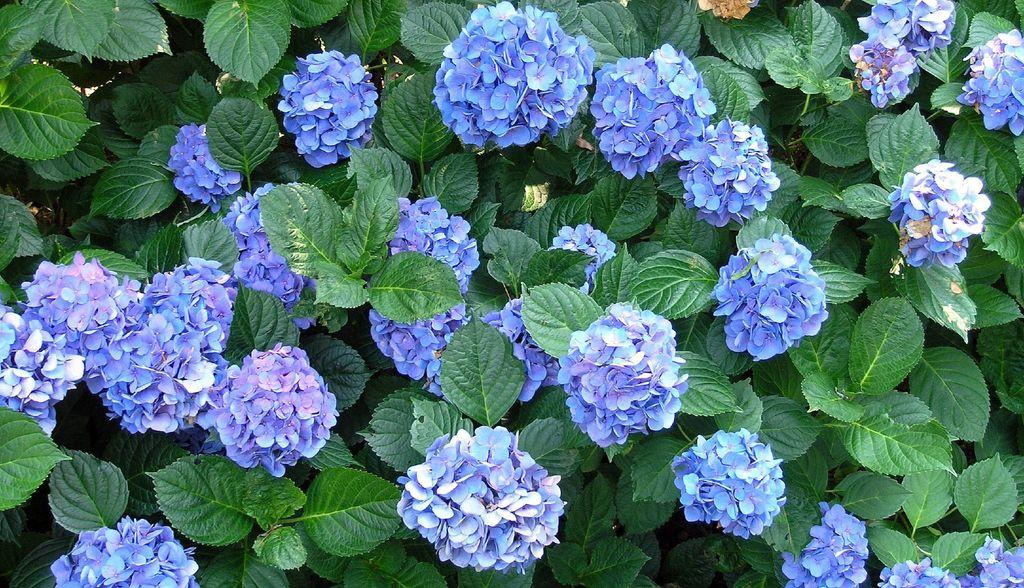What color are the flowers in the image? The flowers in the image are purple. What are the flowers growing on? The flowers are on plants. What color are the leaves in the image? The leaves in the image are green. Where are the leaves located in the image? The leaves are in the bottom right of the image. What type of scarf is wrapped around the flowers in the image? There is no scarf present in the image; it only features flowers and leaves. 